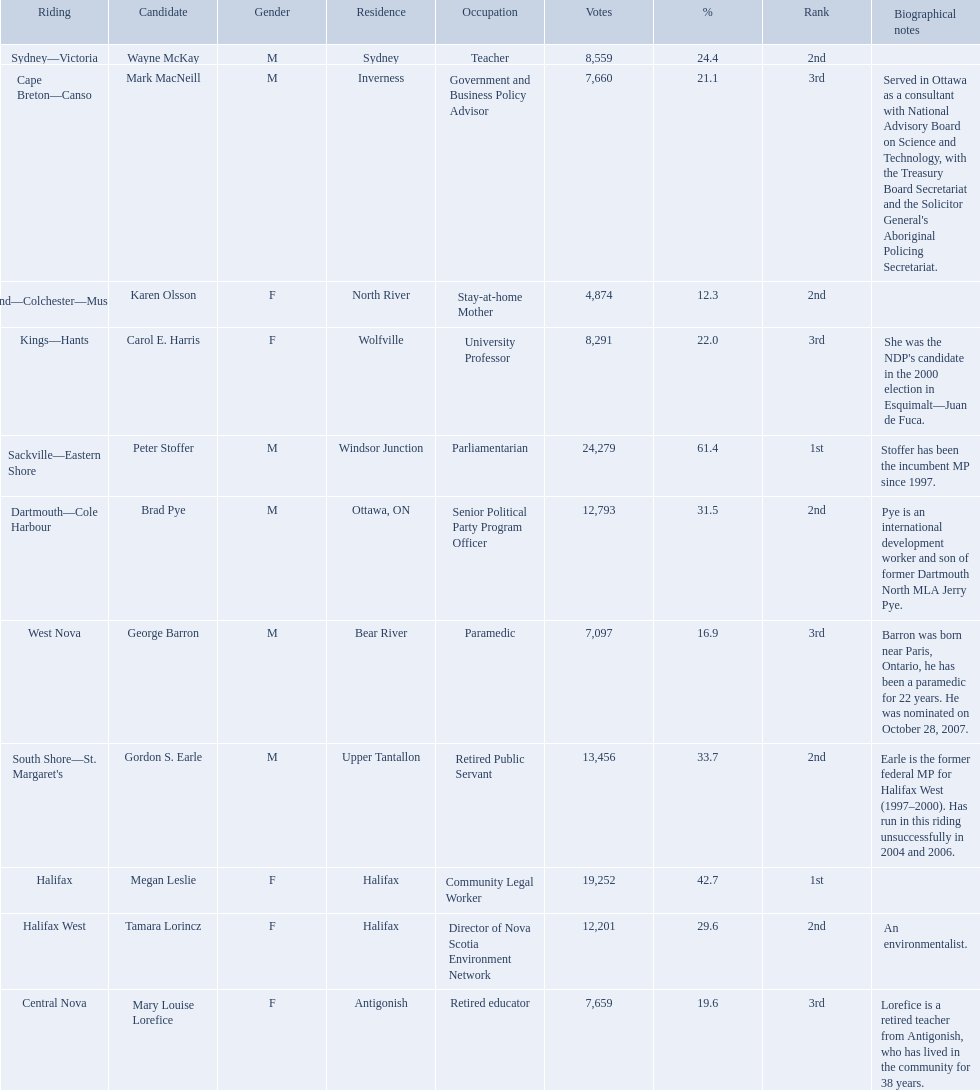What new democratic party candidates ran in the 2008 canadian federal election? Mark MacNeill, Mary Louise Lorefice, Karen Olsson, Brad Pye, Megan Leslie, Tamara Lorincz, Carol E. Harris, Peter Stoffer, Gordon S. Earle, Wayne McKay, George Barron. Of these candidates, which are female? Mary Louise Lorefice, Karen Olsson, Megan Leslie, Tamara Lorincz, Carol E. Harris. Which of these candidates resides in halifax? Megan Leslie, Tamara Lorincz. Of the remaining two, which was ranked 1st? Megan Leslie. How many votes did she get? 19,252. 